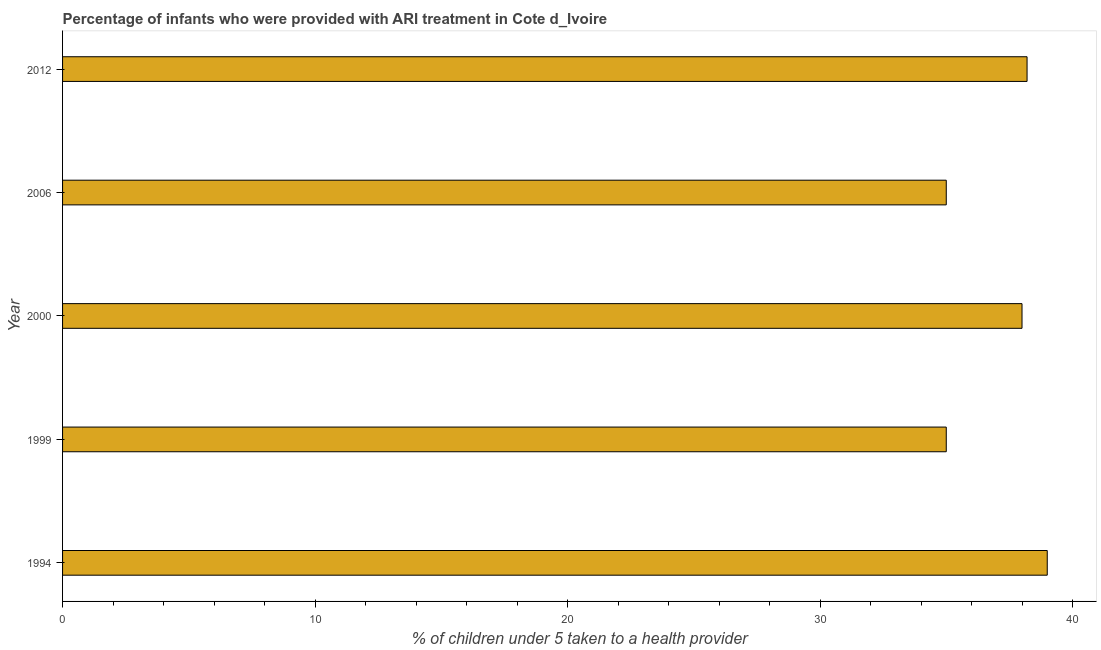Does the graph contain any zero values?
Offer a very short reply. No. Does the graph contain grids?
Give a very brief answer. No. What is the title of the graph?
Keep it short and to the point. Percentage of infants who were provided with ARI treatment in Cote d_Ivoire. What is the label or title of the X-axis?
Provide a succinct answer. % of children under 5 taken to a health provider. Across all years, what is the minimum percentage of children who were provided with ari treatment?
Give a very brief answer. 35. In which year was the percentage of children who were provided with ari treatment minimum?
Provide a short and direct response. 1999. What is the sum of the percentage of children who were provided with ari treatment?
Provide a succinct answer. 185.2. What is the difference between the percentage of children who were provided with ari treatment in 2000 and 2012?
Your answer should be very brief. -0.2. What is the average percentage of children who were provided with ari treatment per year?
Make the answer very short. 37.04. What is the median percentage of children who were provided with ari treatment?
Offer a very short reply. 38. Do a majority of the years between 1999 and 2000 (inclusive) have percentage of children who were provided with ari treatment greater than 30 %?
Your answer should be compact. Yes. Is the percentage of children who were provided with ari treatment in 1994 less than that in 2006?
Make the answer very short. No. Is the difference between the percentage of children who were provided with ari treatment in 1999 and 2012 greater than the difference between any two years?
Your answer should be very brief. No. What is the difference between the highest and the second highest percentage of children who were provided with ari treatment?
Keep it short and to the point. 0.8. What is the difference between the highest and the lowest percentage of children who were provided with ari treatment?
Offer a terse response. 4. Are all the bars in the graph horizontal?
Your answer should be compact. Yes. How many years are there in the graph?
Offer a terse response. 5. What is the difference between two consecutive major ticks on the X-axis?
Your answer should be compact. 10. Are the values on the major ticks of X-axis written in scientific E-notation?
Provide a succinct answer. No. What is the % of children under 5 taken to a health provider in 2012?
Your answer should be compact. 38.2. What is the difference between the % of children under 5 taken to a health provider in 1994 and 2000?
Offer a very short reply. 1. What is the difference between the % of children under 5 taken to a health provider in 1994 and 2012?
Provide a succinct answer. 0.8. What is the difference between the % of children under 5 taken to a health provider in 1999 and 2000?
Your answer should be very brief. -3. What is the difference between the % of children under 5 taken to a health provider in 1999 and 2012?
Offer a very short reply. -3.2. What is the difference between the % of children under 5 taken to a health provider in 2000 and 2006?
Your response must be concise. 3. What is the difference between the % of children under 5 taken to a health provider in 2000 and 2012?
Your response must be concise. -0.2. What is the difference between the % of children under 5 taken to a health provider in 2006 and 2012?
Keep it short and to the point. -3.2. What is the ratio of the % of children under 5 taken to a health provider in 1994 to that in 1999?
Your response must be concise. 1.11. What is the ratio of the % of children under 5 taken to a health provider in 1994 to that in 2000?
Give a very brief answer. 1.03. What is the ratio of the % of children under 5 taken to a health provider in 1994 to that in 2006?
Give a very brief answer. 1.11. What is the ratio of the % of children under 5 taken to a health provider in 1999 to that in 2000?
Offer a very short reply. 0.92. What is the ratio of the % of children under 5 taken to a health provider in 1999 to that in 2006?
Your answer should be compact. 1. What is the ratio of the % of children under 5 taken to a health provider in 1999 to that in 2012?
Keep it short and to the point. 0.92. What is the ratio of the % of children under 5 taken to a health provider in 2000 to that in 2006?
Keep it short and to the point. 1.09. What is the ratio of the % of children under 5 taken to a health provider in 2006 to that in 2012?
Your answer should be very brief. 0.92. 